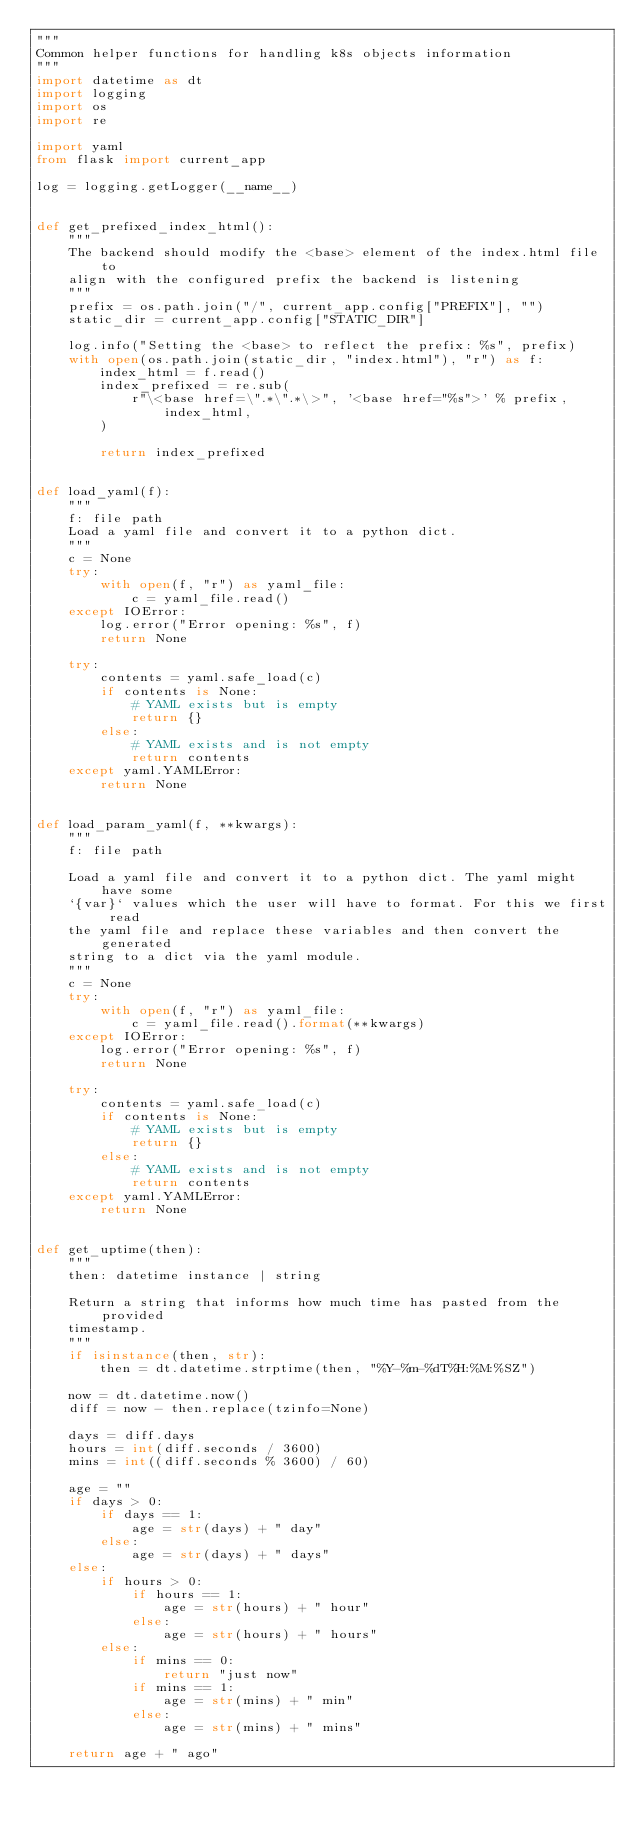Convert code to text. <code><loc_0><loc_0><loc_500><loc_500><_Python_>"""
Common helper functions for handling k8s objects information
"""
import datetime as dt
import logging
import os
import re

import yaml
from flask import current_app

log = logging.getLogger(__name__)


def get_prefixed_index_html():
    """
    The backend should modify the <base> element of the index.html file to
    align with the configured prefix the backend is listening
    """
    prefix = os.path.join("/", current_app.config["PREFIX"], "")
    static_dir = current_app.config["STATIC_DIR"]

    log.info("Setting the <base> to reflect the prefix: %s", prefix)
    with open(os.path.join(static_dir, "index.html"), "r") as f:
        index_html = f.read()
        index_prefixed = re.sub(
            r"\<base href=\".*\".*\>", '<base href="%s">' % prefix, index_html,
        )

        return index_prefixed


def load_yaml(f):
    """
    f: file path
    Load a yaml file and convert it to a python dict.
    """
    c = None
    try:
        with open(f, "r") as yaml_file:
            c = yaml_file.read()
    except IOError:
        log.error("Error opening: %s", f)
        return None

    try:
        contents = yaml.safe_load(c)
        if contents is None:
            # YAML exists but is empty
            return {}
        else:
            # YAML exists and is not empty
            return contents
    except yaml.YAMLError:
        return None


def load_param_yaml(f, **kwargs):
    """
    f: file path

    Load a yaml file and convert it to a python dict. The yaml might have some
    `{var}` values which the user will have to format. For this we first read
    the yaml file and replace these variables and then convert the generated
    string to a dict via the yaml module.
    """
    c = None
    try:
        with open(f, "r") as yaml_file:
            c = yaml_file.read().format(**kwargs)
    except IOError:
        log.error("Error opening: %s", f)
        return None

    try:
        contents = yaml.safe_load(c)
        if contents is None:
            # YAML exists but is empty
            return {}
        else:
            # YAML exists and is not empty
            return contents
    except yaml.YAMLError:
        return None


def get_uptime(then):
    """
    then: datetime instance | string

    Return a string that informs how much time has pasted from the provided
    timestamp.
    """
    if isinstance(then, str):
        then = dt.datetime.strptime(then, "%Y-%m-%dT%H:%M:%SZ")

    now = dt.datetime.now()
    diff = now - then.replace(tzinfo=None)

    days = diff.days
    hours = int(diff.seconds / 3600)
    mins = int((diff.seconds % 3600) / 60)

    age = ""
    if days > 0:
        if days == 1:
            age = str(days) + " day"
        else:
            age = str(days) + " days"
    else:
        if hours > 0:
            if hours == 1:
                age = str(hours) + " hour"
            else:
                age = str(hours) + " hours"
        else:
            if mins == 0:
                return "just now"
            if mins == 1:
                age = str(mins) + " min"
            else:
                age = str(mins) + " mins"

    return age + " ago"
</code> 